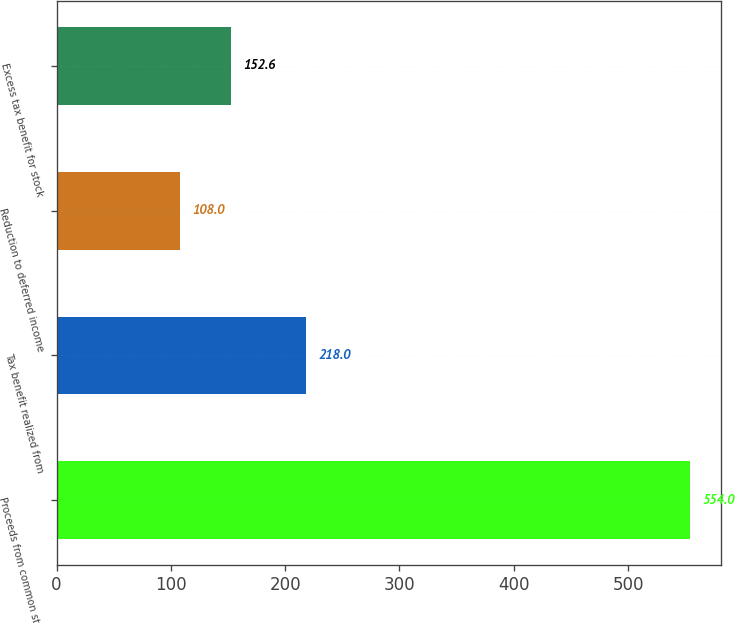<chart> <loc_0><loc_0><loc_500><loc_500><bar_chart><fcel>Proceeds from common stock<fcel>Tax benefit realized from<fcel>Reduction to deferred income<fcel>Excess tax benefit for stock<nl><fcel>554<fcel>218<fcel>108<fcel>152.6<nl></chart> 